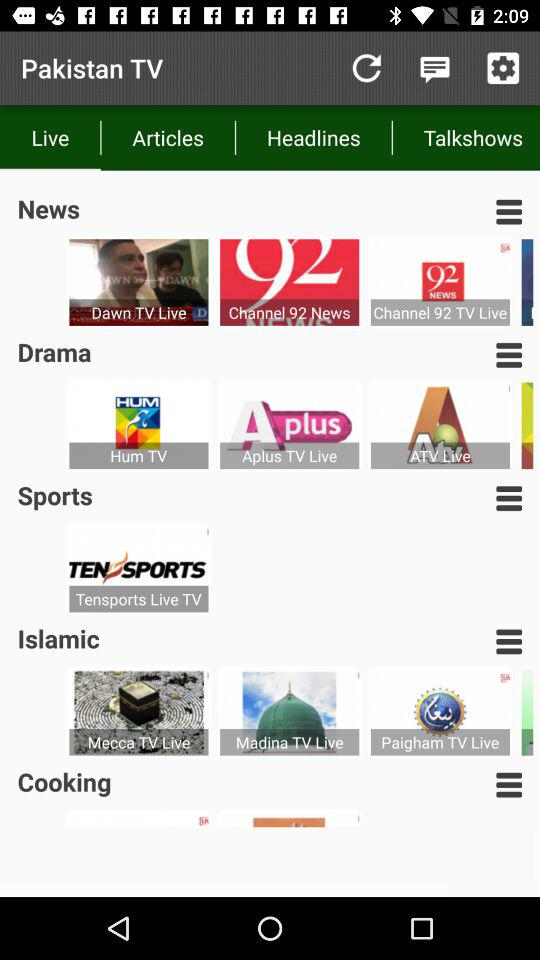What is the application name? The application name is "Pakistan TV". 